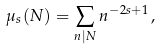<formula> <loc_0><loc_0><loc_500><loc_500>\mu _ { s } ( N ) = \sum _ { n | N } n ^ { - 2 s + 1 } \, ,</formula> 